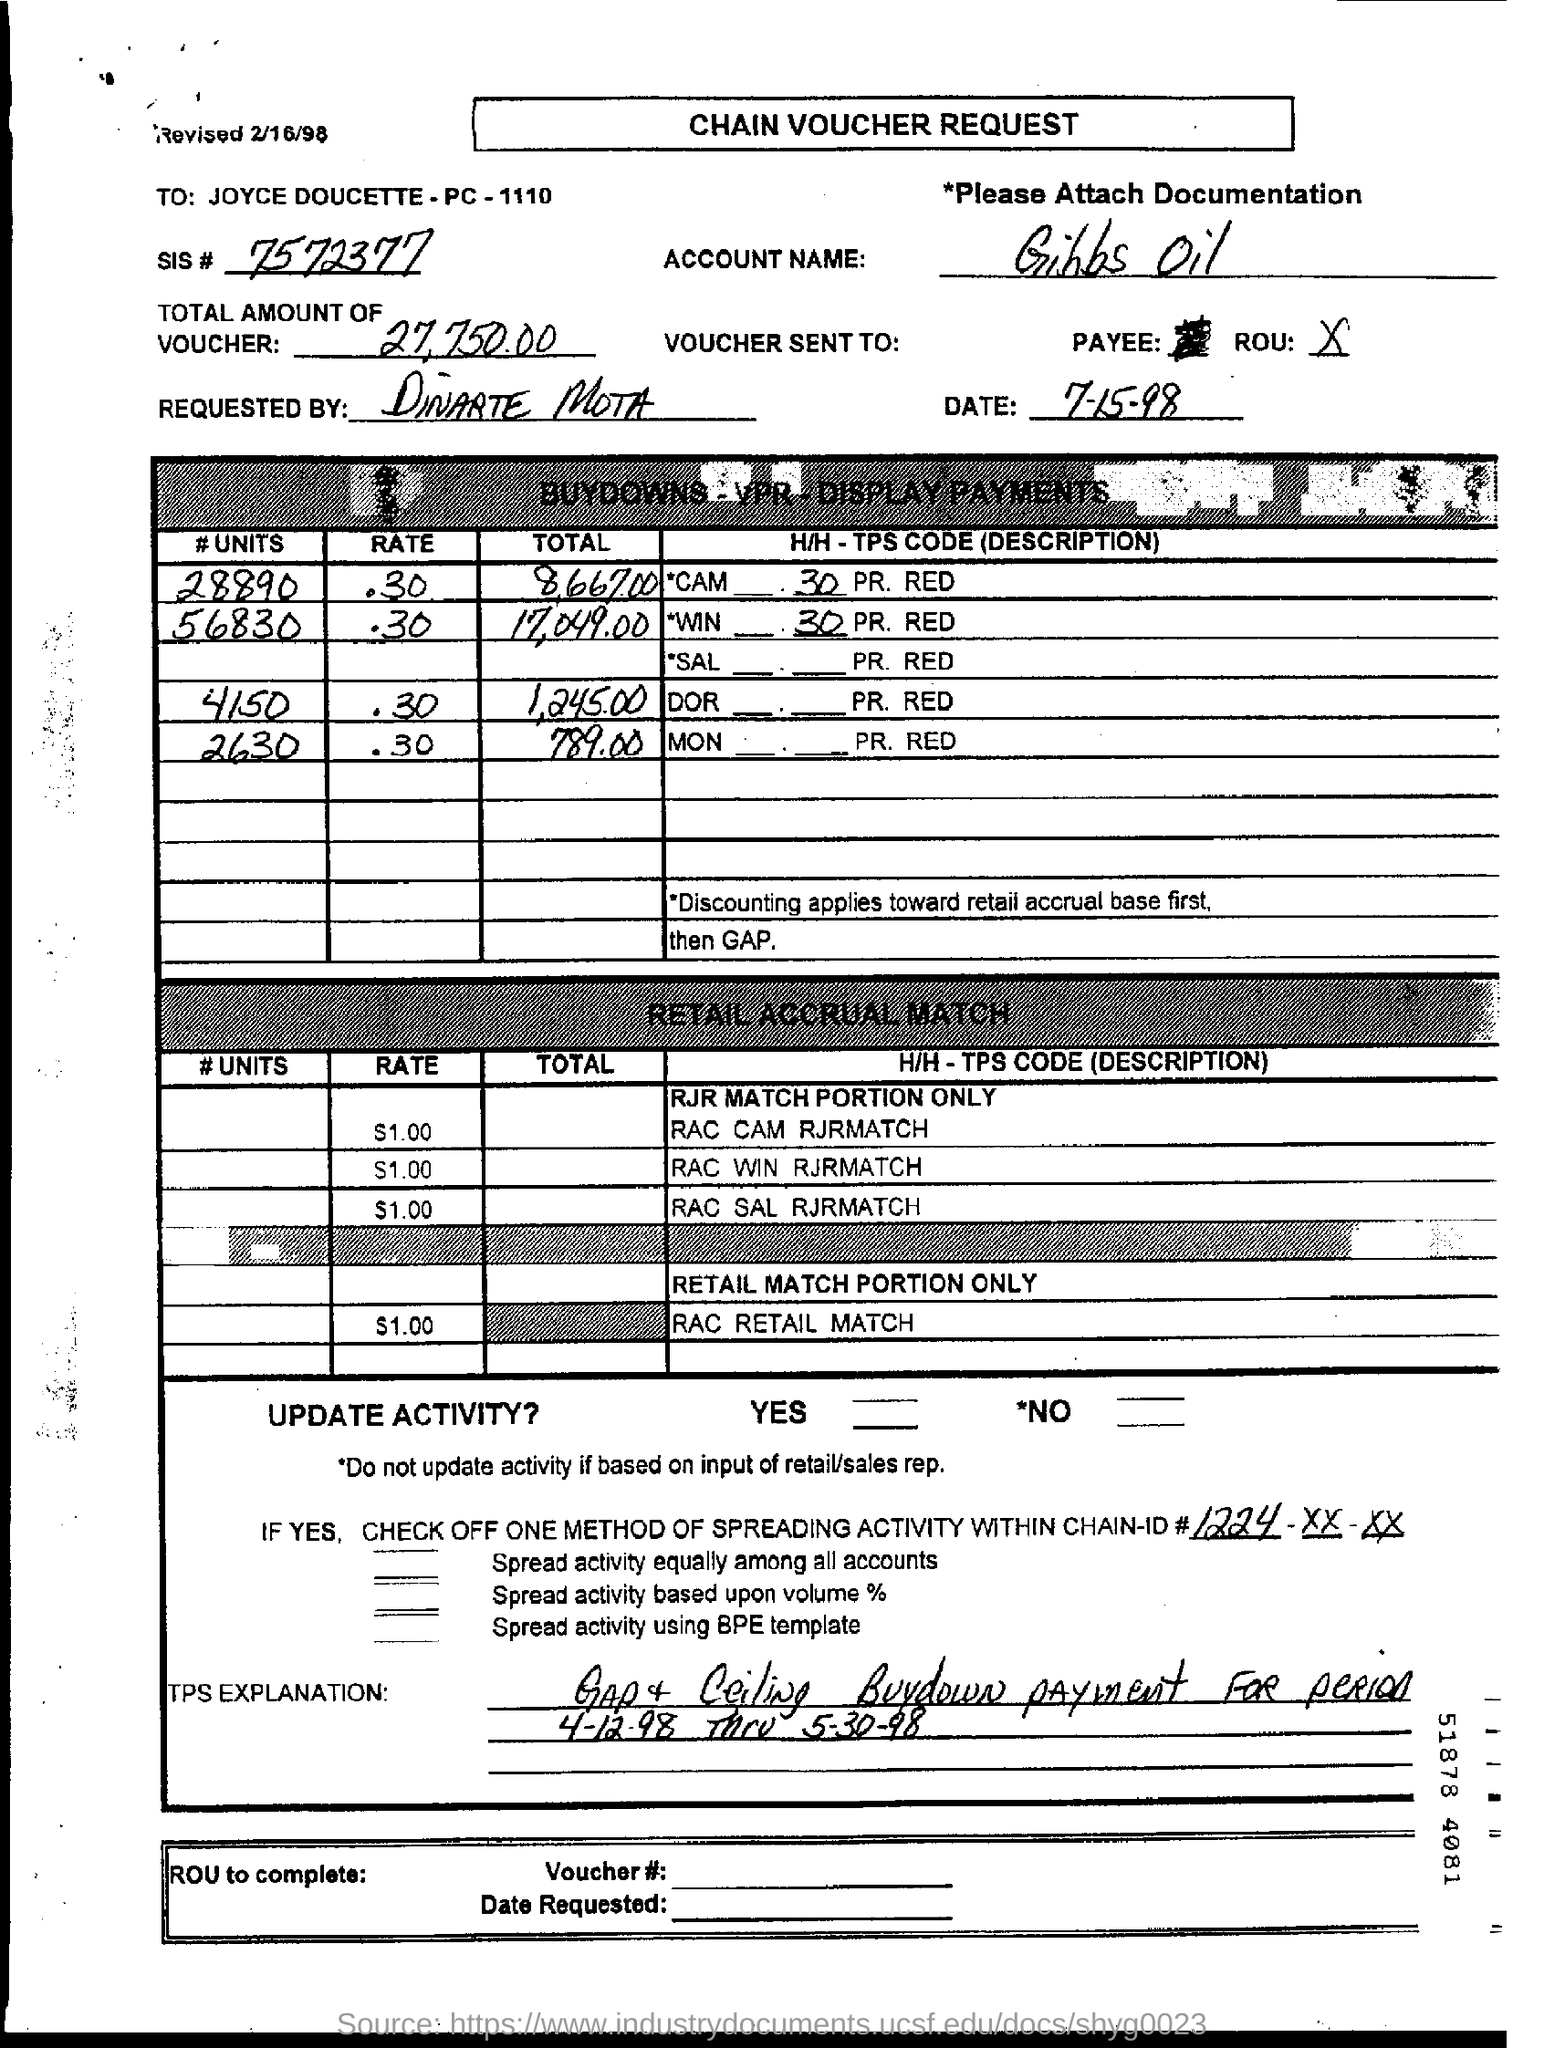What is the account name mentioned ?
Give a very brief answer. Gibbs oil. What is the name of the requested by mentioned ?
Keep it short and to the point. Dinarte mota. What is the sis no. mentioned ?
Your answer should be compact. 7572377. 